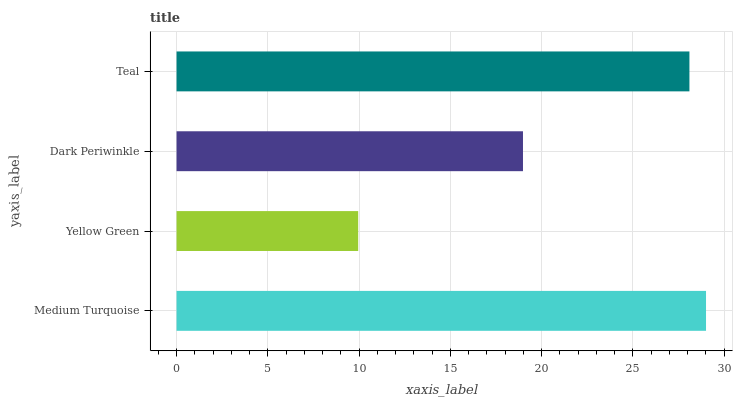Is Yellow Green the minimum?
Answer yes or no. Yes. Is Medium Turquoise the maximum?
Answer yes or no. Yes. Is Dark Periwinkle the minimum?
Answer yes or no. No. Is Dark Periwinkle the maximum?
Answer yes or no. No. Is Dark Periwinkle greater than Yellow Green?
Answer yes or no. Yes. Is Yellow Green less than Dark Periwinkle?
Answer yes or no. Yes. Is Yellow Green greater than Dark Periwinkle?
Answer yes or no. No. Is Dark Periwinkle less than Yellow Green?
Answer yes or no. No. Is Teal the high median?
Answer yes or no. Yes. Is Dark Periwinkle the low median?
Answer yes or no. Yes. Is Medium Turquoise the high median?
Answer yes or no. No. Is Teal the low median?
Answer yes or no. No. 